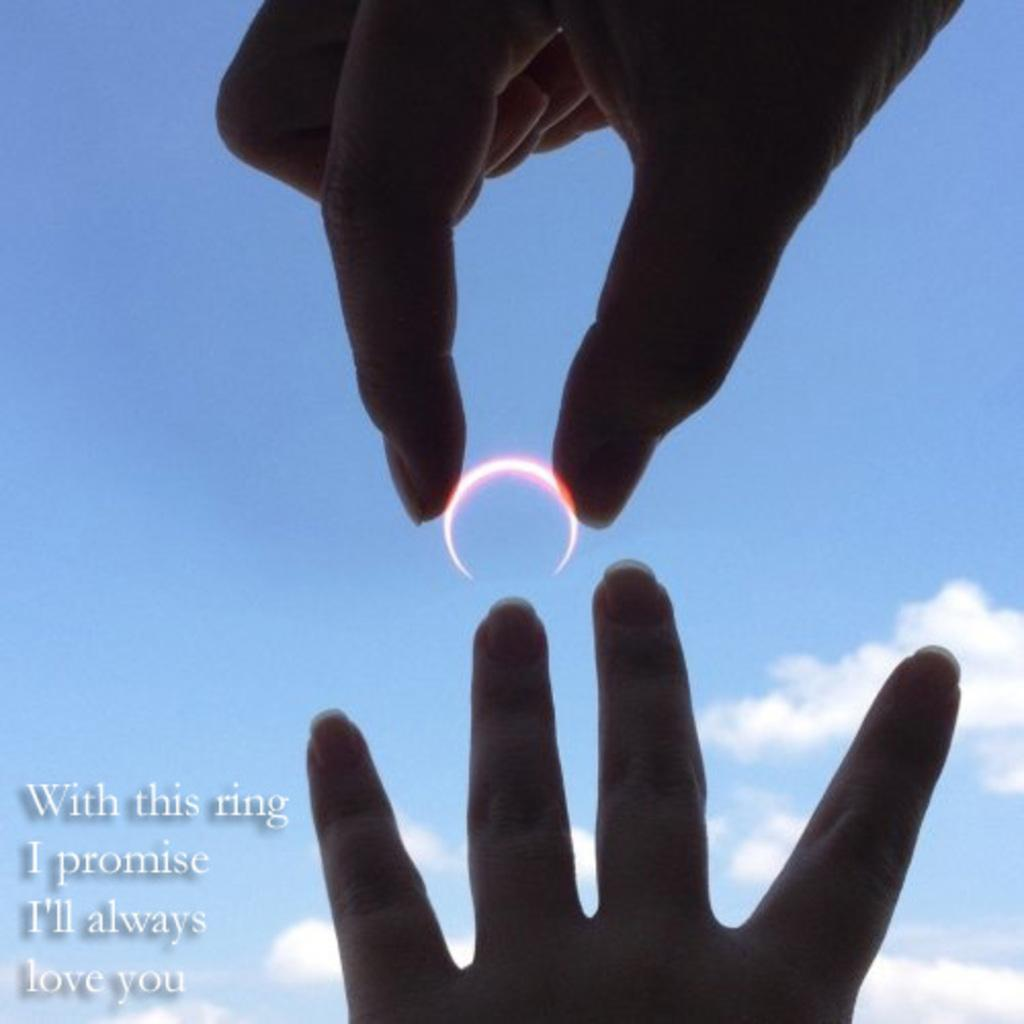What object is being held in a person's hand in the image? There is a ring in a person's hand in the image. Can you describe the other hand visible in the image? There is another hand visible in the image, but it is not holding any object. How would you describe the sky in the image? The sky is blue and cloudy in the image. What can be seen on the left side of the image? There is text on the left side of the image. What type of instrument is being played by the person in the image? There is no instrument being played in the image; the focus is on the ring in a person's hand. 